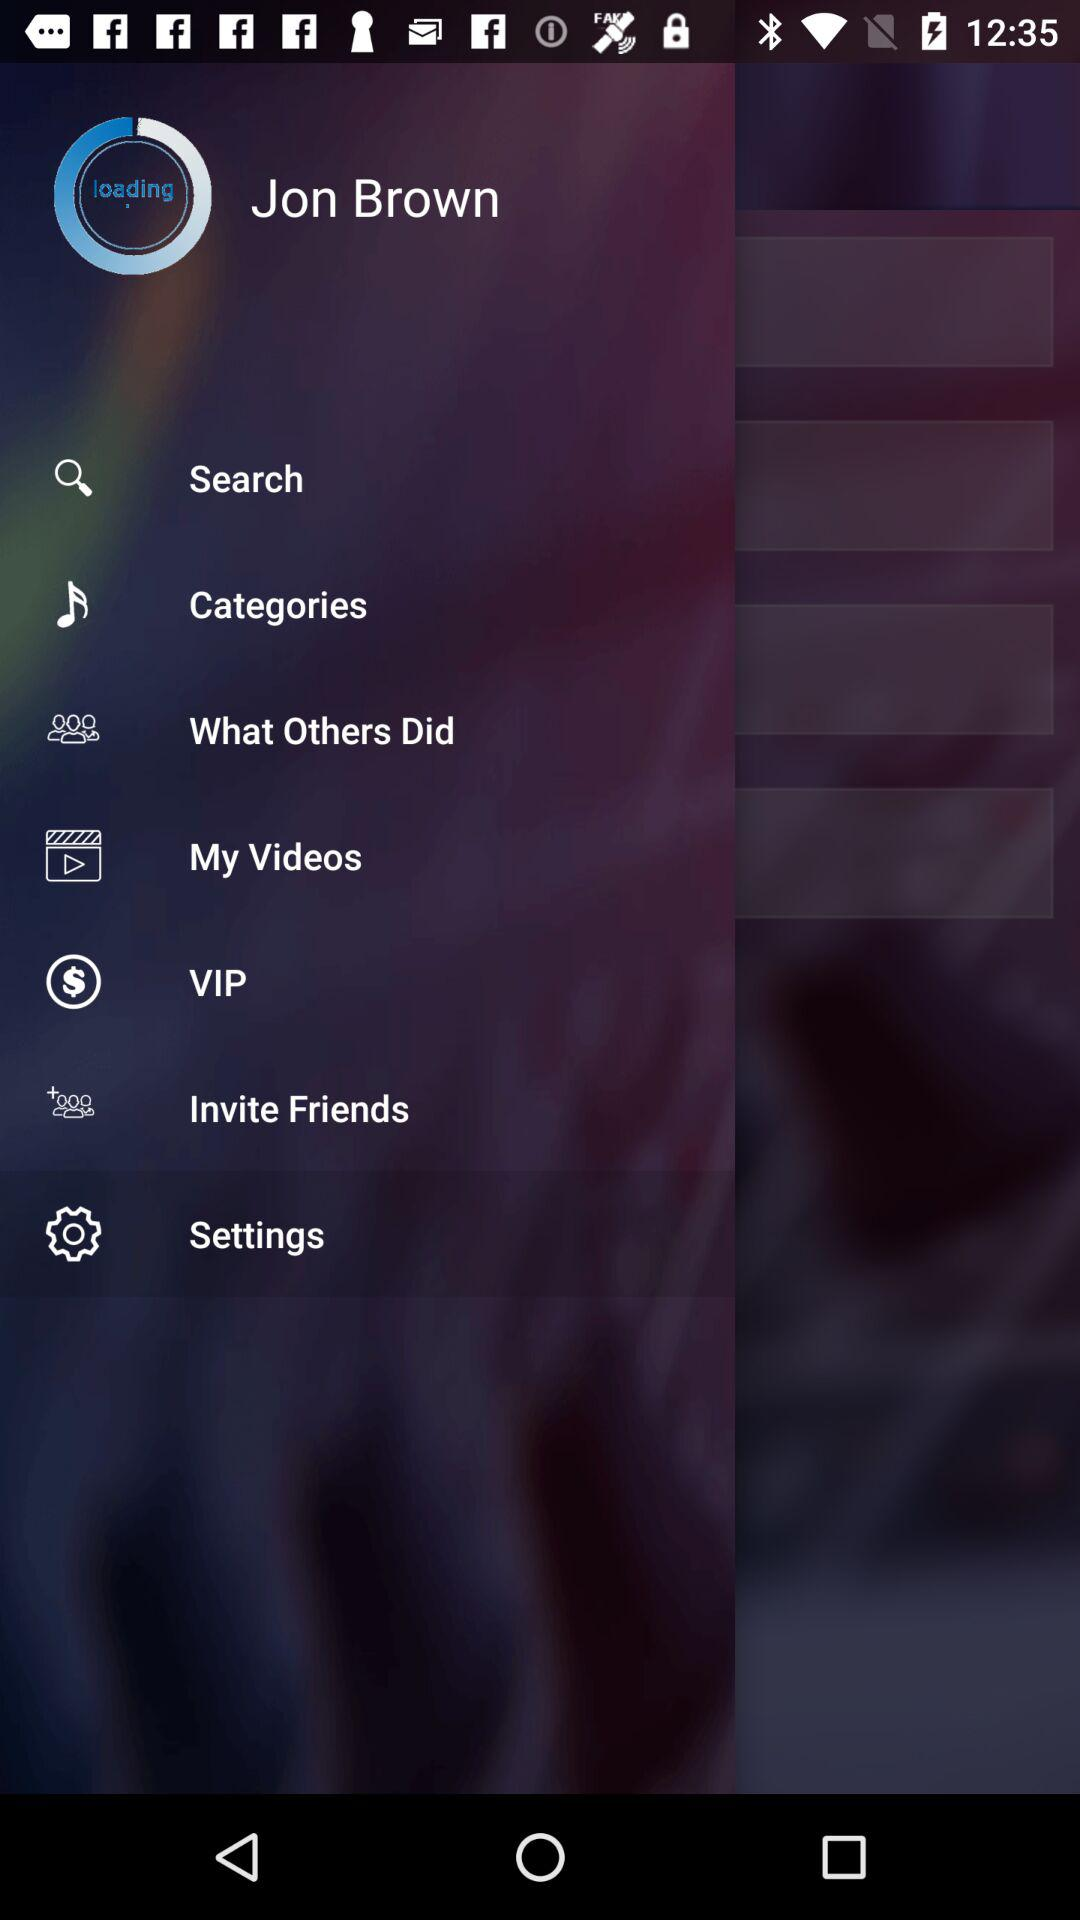What is the user name? The user name is "Jon Brown". 